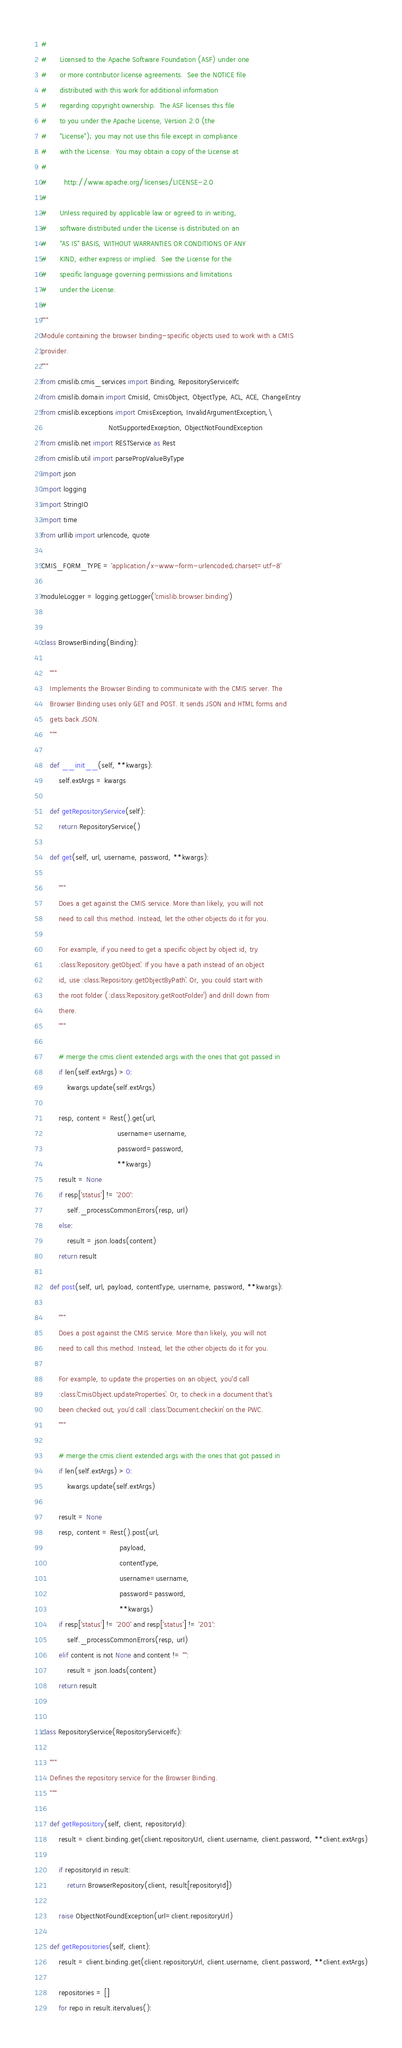<code> <loc_0><loc_0><loc_500><loc_500><_Python_>#
#      Licensed to the Apache Software Foundation (ASF) under one
#      or more contributor license agreements.  See the NOTICE file
#      distributed with this work for additional information
#      regarding copyright ownership.  The ASF licenses this file
#      to you under the Apache License, Version 2.0 (the
#      "License"); you may not use this file except in compliance
#      with the License.  You may obtain a copy of the License at
#
#        http://www.apache.org/licenses/LICENSE-2.0
#
#      Unless required by applicable law or agreed to in writing,
#      software distributed under the License is distributed on an
#      "AS IS" BASIS, WITHOUT WARRANTIES OR CONDITIONS OF ANY
#      KIND, either express or implied.  See the License for the
#      specific language governing permissions and limitations
#      under the License.
#
"""
Module containing the browser binding-specific objects used to work with a CMIS
provider.
"""
from cmislib.cmis_services import Binding, RepositoryServiceIfc
from cmislib.domain import CmisId, CmisObject, ObjectType, ACL, ACE, ChangeEntry
from cmislib.exceptions import CmisException, InvalidArgumentException,\
                               NotSupportedException, ObjectNotFoundException
from cmislib.net import RESTService as Rest
from cmislib.util import parsePropValueByType
import json
import logging
import StringIO
import time
from urllib import urlencode, quote

CMIS_FORM_TYPE = 'application/x-www-form-urlencoded;charset=utf-8'

moduleLogger = logging.getLogger('cmislib.browser.binding')


class BrowserBinding(Binding):

    """
    Implements the Browser Binding to communicate with the CMIS server. The
    Browser Binding uses only GET and POST. It sends JSON and HTML forms and
    gets back JSON.
    """

    def __init__(self, **kwargs):
        self.extArgs = kwargs

    def getRepositoryService(self):
        return RepositoryService()

    def get(self, url, username, password, **kwargs):

        """
        Does a get against the CMIS service. More than likely, you will not
        need to call this method. Instead, let the other objects do it for you.

        For example, if you need to get a specific object by object id, try
        :class:`Repository.getObject`. If you have a path instead of an object
        id, use :class:`Repository.getObjectByPath`. Or, you could start with
        the root folder (:class:`Repository.getRootFolder`) and drill down from
        there.
        """

        # merge the cmis client extended args with the ones that got passed in
        if len(self.extArgs) > 0:
            kwargs.update(self.extArgs)

        resp, content = Rest().get(url,
                                   username=username,
                                   password=password,
                                   **kwargs)
        result = None
        if resp['status'] != '200':
            self._processCommonErrors(resp, url)
        else:
            result = json.loads(content)
        return result

    def post(self, url, payload, contentType, username, password, **kwargs):

        """
        Does a post against the CMIS service. More than likely, you will not
        need to call this method. Instead, let the other objects do it for you.

        For example, to update the properties on an object, you'd call
        :class:`CmisObject.updateProperties`. Or, to check in a document that's
        been checked out, you'd call :class:`Document.checkin` on the PWC.
        """

        # merge the cmis client extended args with the ones that got passed in
        if len(self.extArgs) > 0:
            kwargs.update(self.extArgs)

        result = None
        resp, content = Rest().post(url,
                                    payload,
                                    contentType,
                                    username=username,
                                    password=password,
                                    **kwargs)
        if resp['status'] != '200' and resp['status'] != '201':
            self._processCommonErrors(resp, url)
        elif content is not None and content != "":
            result = json.loads(content)
        return result


class RepositoryService(RepositoryServiceIfc):

    """
    Defines the repository service for the Browser Binding.
    """

    def getRepository(self, client, repositoryId):
        result = client.binding.get(client.repositoryUrl, client.username, client.password, **client.extArgs)

        if repositoryId in result:
            return BrowserRepository(client, result[repositoryId])

        raise ObjectNotFoundException(url=client.repositoryUrl)

    def getRepositories(self, client):
        result = client.binding.get(client.repositoryUrl, client.username, client.password, **client.extArgs)

        repositories = []
        for repo in result.itervalues():</code> 